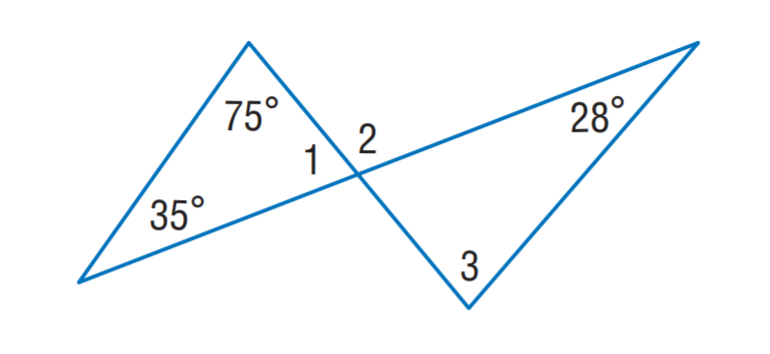Answer the mathemtical geometry problem and directly provide the correct option letter.
Question: Find m \angle 2.
Choices: A: 82 B: 99 C: 110 D: 112 C 